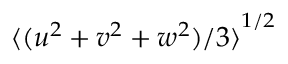Convert formula to latex. <formula><loc_0><loc_0><loc_500><loc_500>{ \langle ( u ^ { 2 } + v ^ { 2 } + w ^ { 2 } ) / 3 \rangle } ^ { 1 / 2 }</formula> 